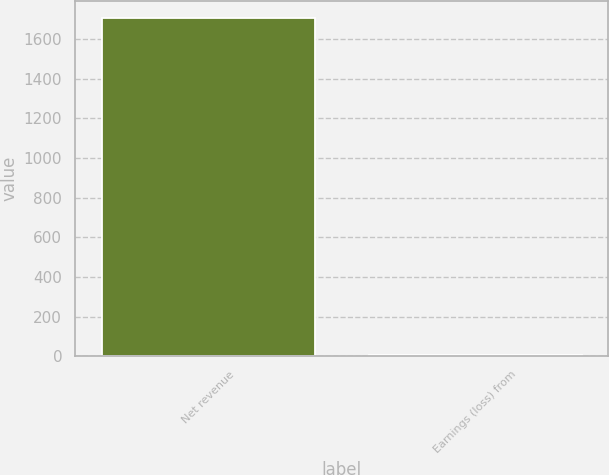<chart> <loc_0><loc_0><loc_500><loc_500><bar_chart><fcel>Net revenue<fcel>Earnings (loss) from<nl><fcel>1707<fcel>7.9<nl></chart> 